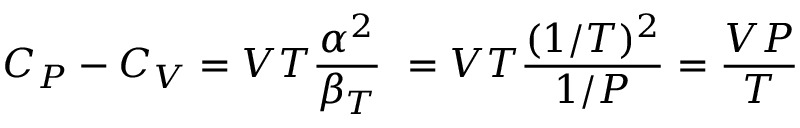<formula> <loc_0><loc_0><loc_500><loc_500>C _ { P } - C _ { V } = V T { \frac { \alpha ^ { 2 } } { \beta _ { T } } } \ = V T { \frac { ( 1 / T ) ^ { 2 } } { 1 / P } } = { \frac { V P } { T } }</formula> 